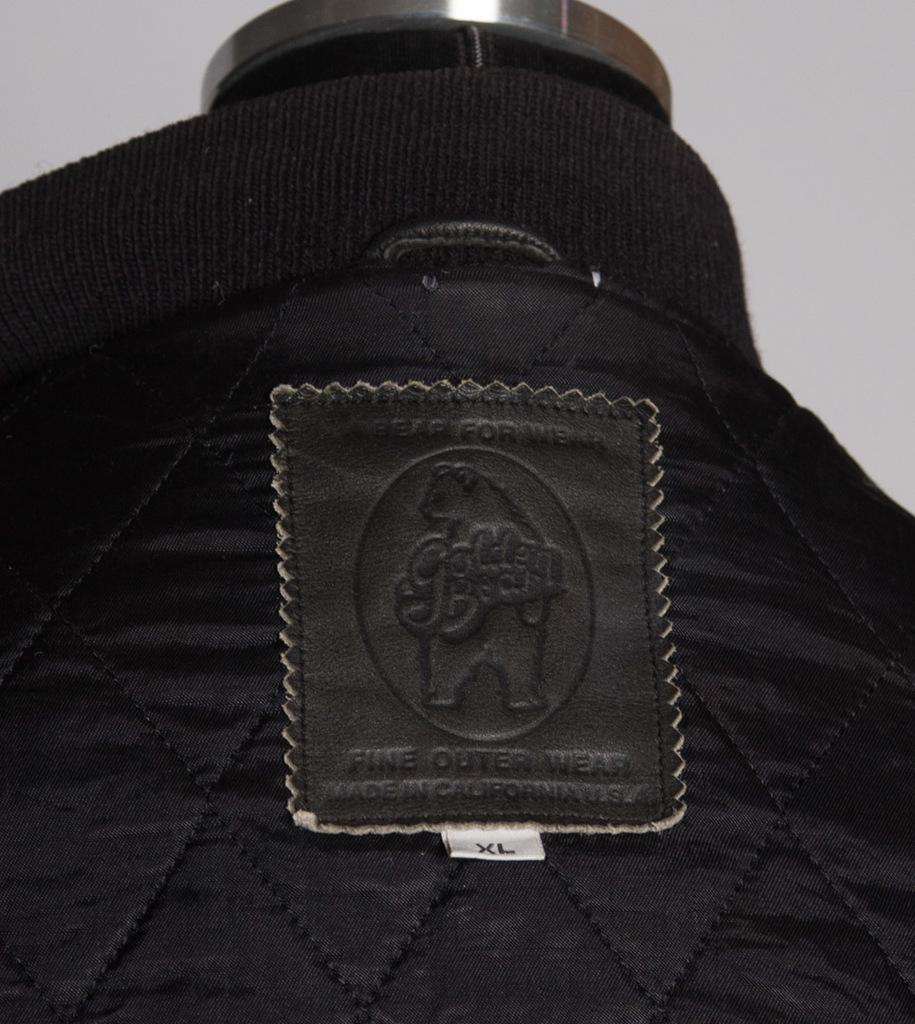What color is the cloth that is visible in the image? The cloth in the image is black. Is there any additional information about the black cloth? Yes, there is a label attached to the black cloth. What can be found on the label? There is text on the label. What is the metal object at the top of the image? The metal object at the top of the image is not specified in the provided facts. What time of day does the pencil cause the afternoon to occur in the image? There is no pencil or afternoon mentioned in the image, so this question cannot be answered. 